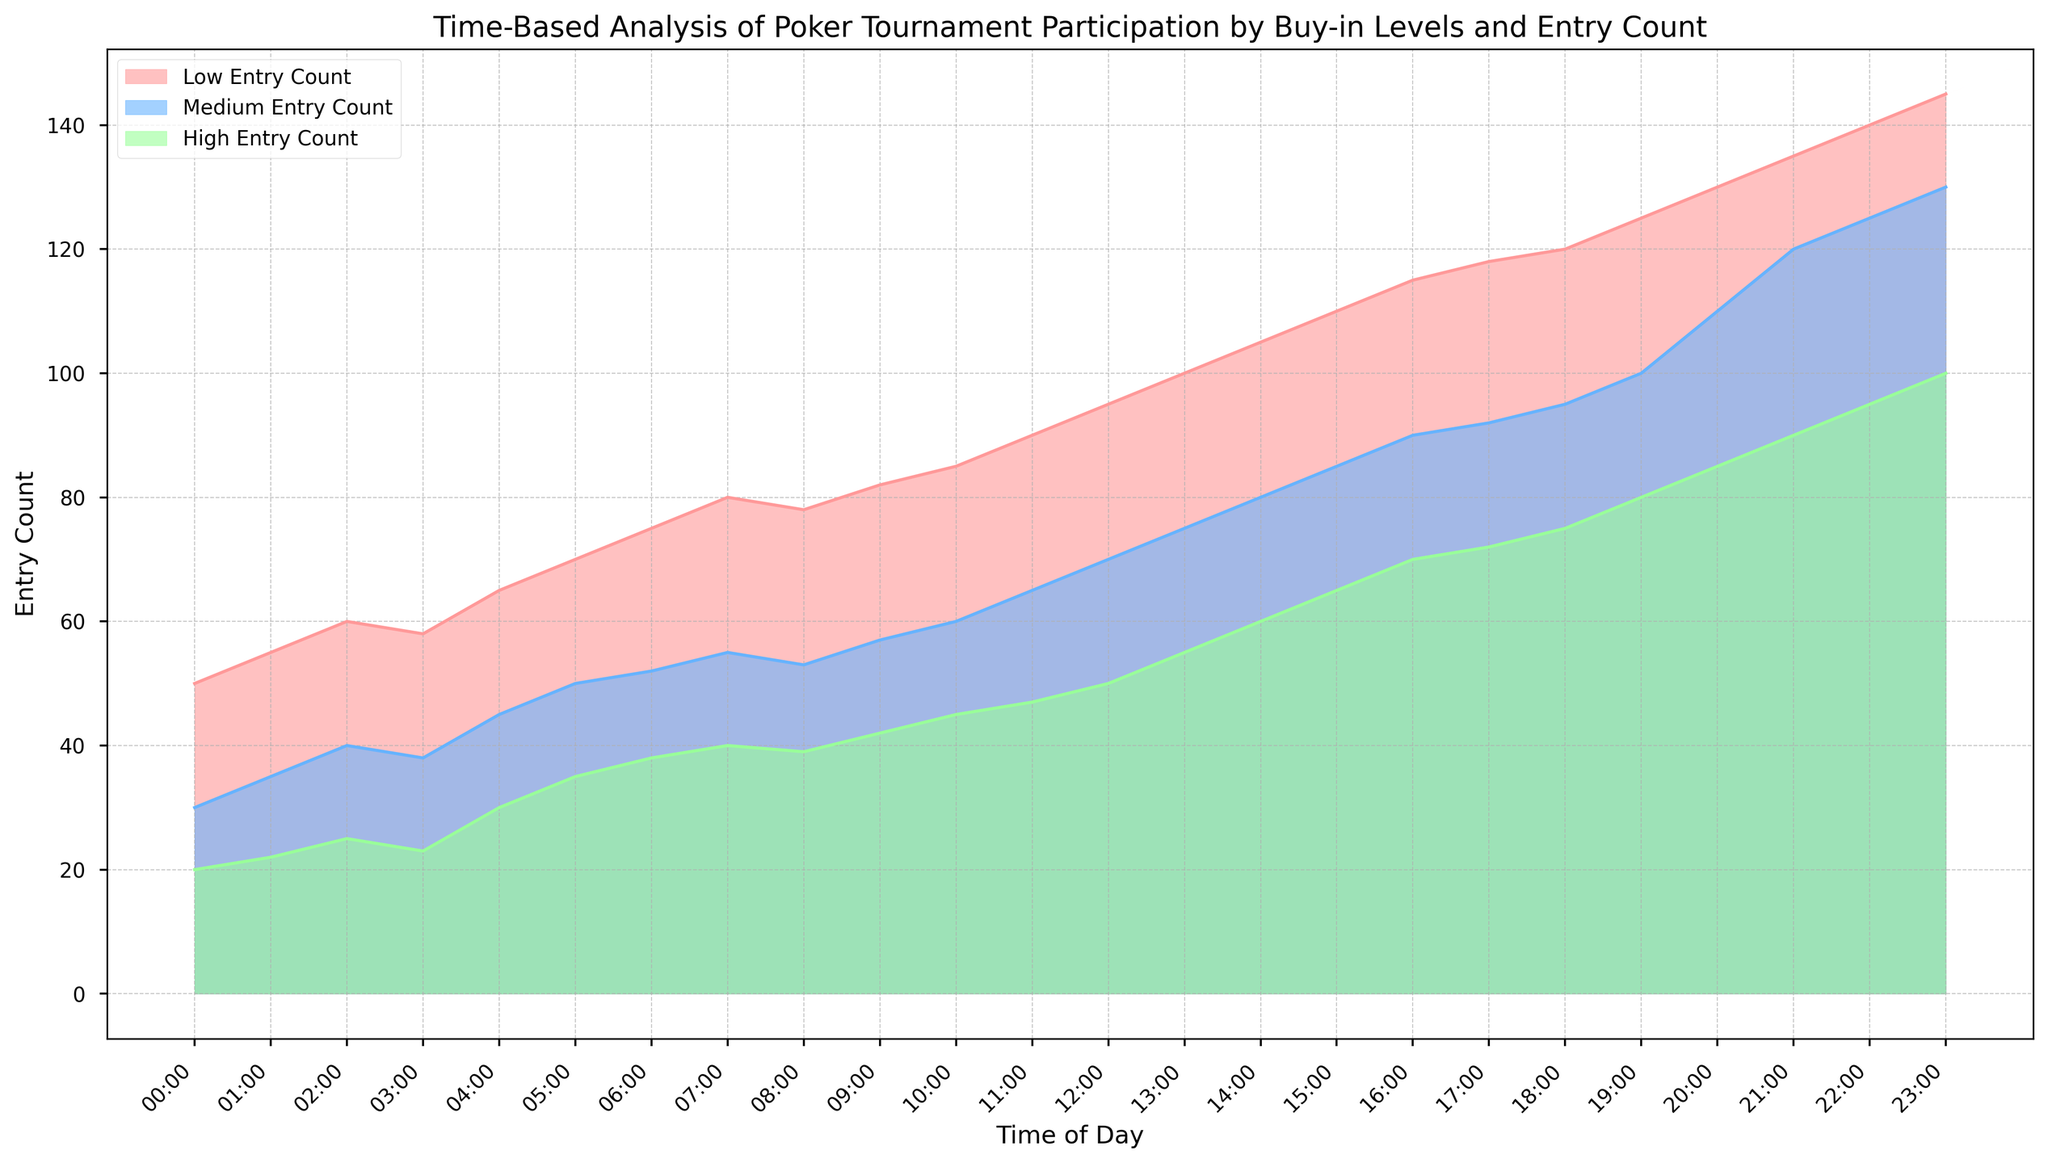How does the entry count for low buy-in levels change from 00:00 to 23:00? To identify the change in entry count for low buy-in levels, look at the area representing low buy-ins (light red). Observe the height at 00:00 (50 entries) and at 23:00 (145 entries).
Answer: Increases from 50 to 145 Which buy-in level consistently has the highest award payouts? Note the relative heights of award payouts for low (light red), medium (light blue), and high (light green) buy-in levels. The high buy-in level consistently has higher award payouts compared to the others.
Answer: High buy-in At what time do medium buy-in levels reach their peak entry count? Examine the area representing medium buy-ins (light blue) and identify the highest point, which corresponds to the peak time.
Answer: 23:00 Compare the increase in entry counts for high buy-in levels between 20:00 and 23:00. Check the entry count at 20:00 (80 entries) and at 23:00 (100 entries) for high buy-in levels (light green). Calculate the difference.
Answer: Increase by 20 What is the difference in award payouts between low and high buy-in levels at 22:00? Find the award payouts for low (1400) and high (14250) buy-in levels at 22:00 and compute the difference.
Answer: 12850 When do all buy-in levels have roughly equal entry counts? Look across the chart for points where the areas for low (light red), medium (light blue), and high (light green) buy-in levels appear similar in height.
Answer: 03:00 What trend is observed in the award payouts as time progresses? Observe how the areas corresponding to award payouts for each buy-in level change from 00:00 to 23:00.
Answer: Increasing trend Which buy-in level grows the fastest in terms of entry count throughout the day? Examine the slope of the areas for each buy-in level from 00:00 to 23:00. Low buy-in levels (light red) show the steepest increase.
Answer: Low buy-in How do entry counts for the high buy-in level change from 06:00 to 12:00? Note the entry counts at 06:00 (38 entries) and 12:00 (50 entries) for high buy-in levels (light green) and calculate the difference.
Answer: Increase by 12 What is the combined entry count for all buy-in levels at 17:00? Add the entry counts for low (118 entries), medium (92 entries), and high (72 entries) buy-in levels at 17:00.
Answer: 282 